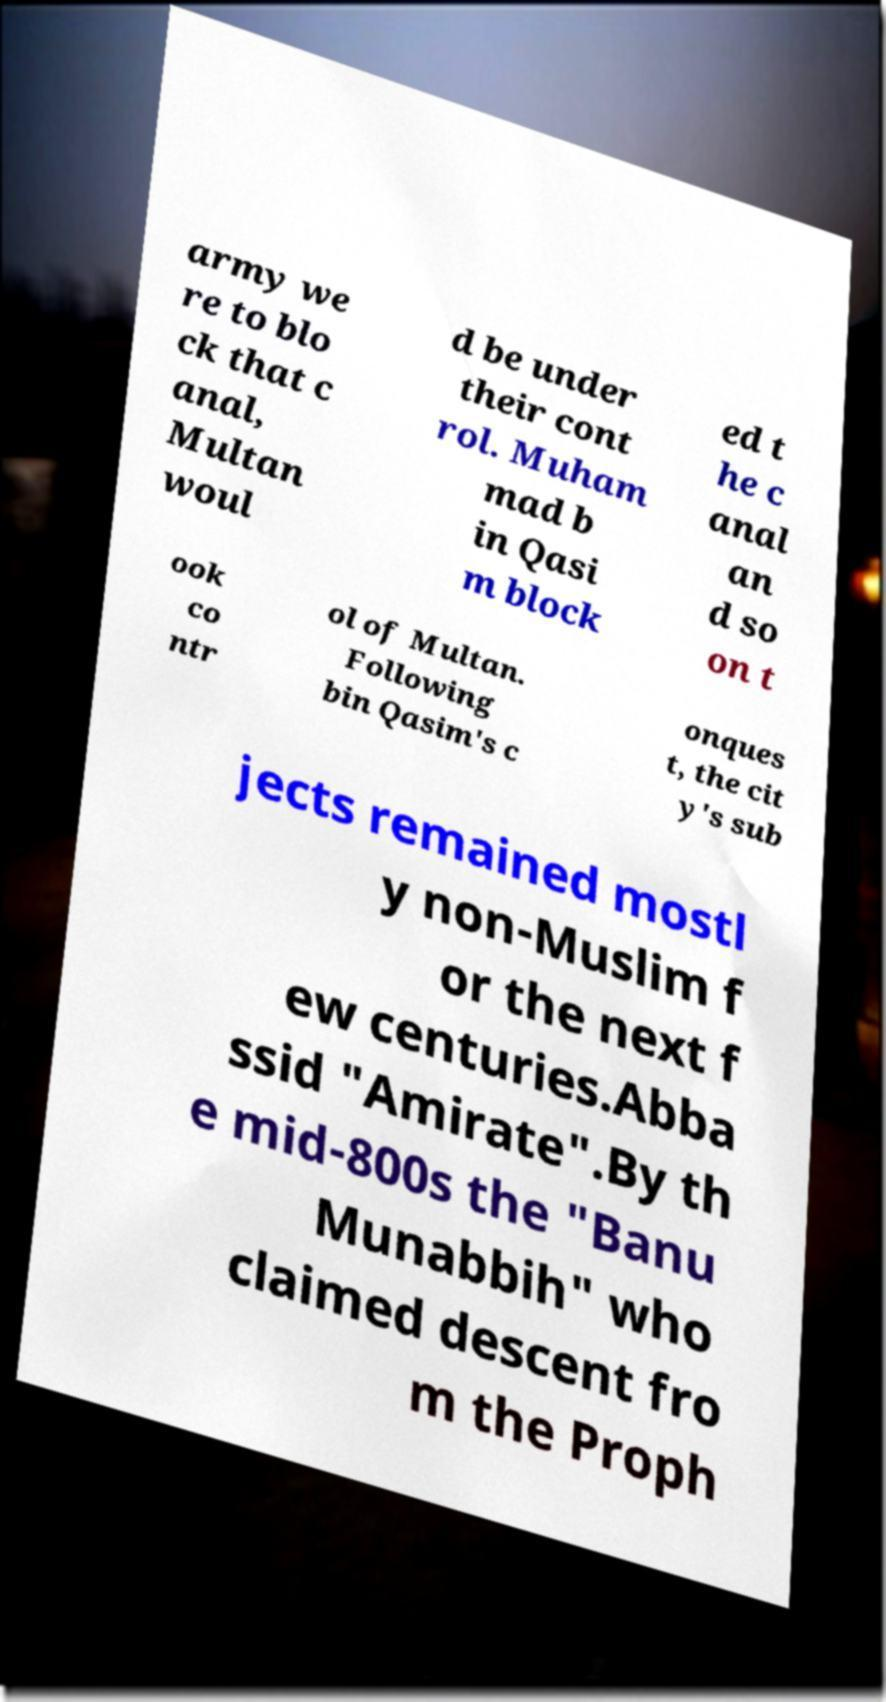There's text embedded in this image that I need extracted. Can you transcribe it verbatim? army we re to blo ck that c anal, Multan woul d be under their cont rol. Muham mad b in Qasi m block ed t he c anal an d so on t ook co ntr ol of Multan. Following bin Qasim's c onques t, the cit y's sub jects remained mostl y non-Muslim f or the next f ew centuries.Abba ssid "Amirate".By th e mid-800s the "Banu Munabbih" who claimed descent fro m the Proph 